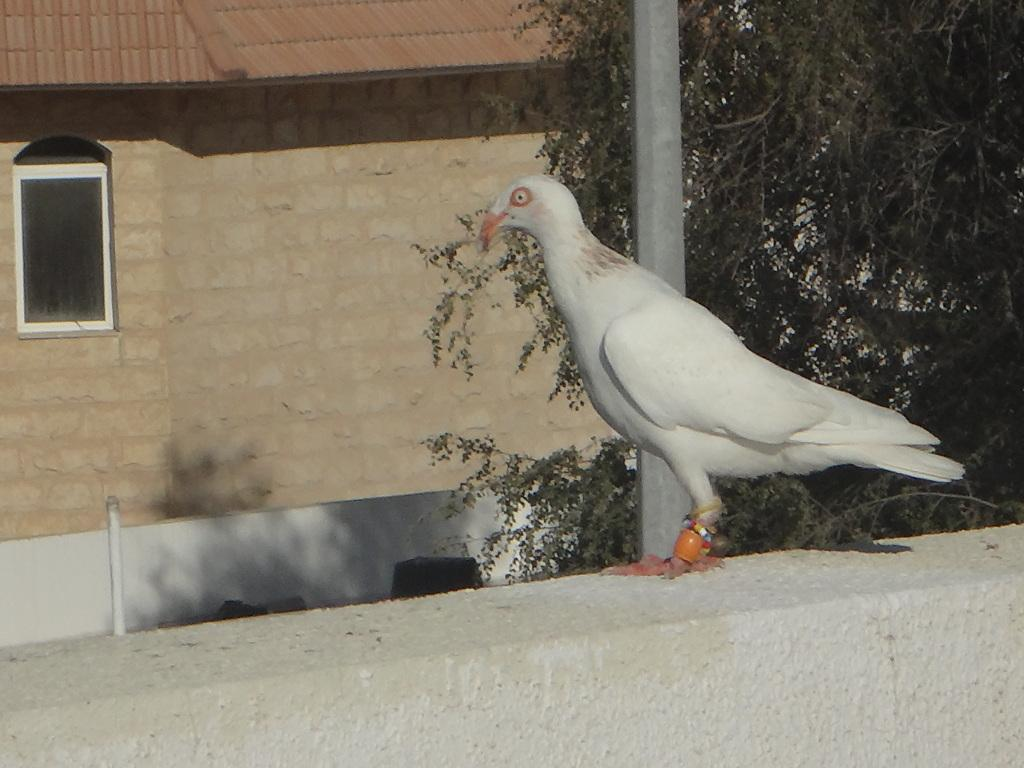What type of bird can be seen on the wall in the image? There is a white color bird on the wall in the image. What can be seen in the background of the image? There is a pole, trees, and a house in the background of the image. What type of toys can be seen on the ground in the image? There are no toys present in the image. What is the bird doing to start the engine in the image? The bird is not interacting with any engine in the image; it is simply perched on the wall. 